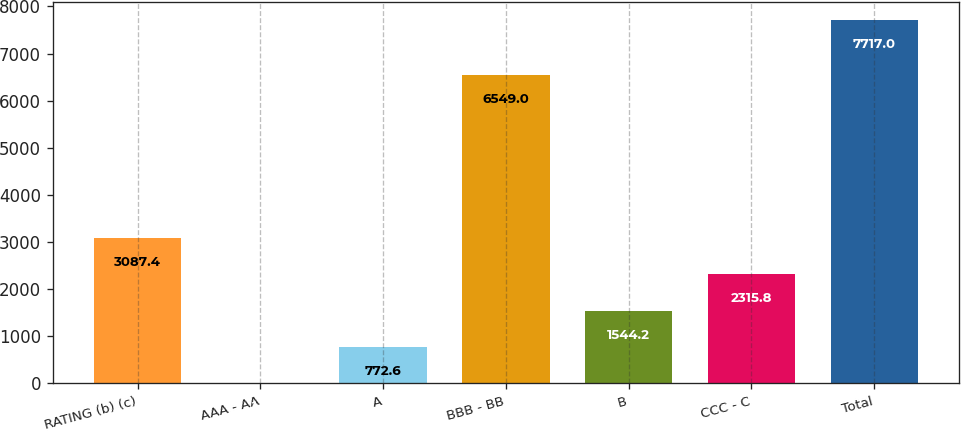<chart> <loc_0><loc_0><loc_500><loc_500><bar_chart><fcel>RATING (b) (c)<fcel>AAA - AA<fcel>A<fcel>BBB - BB<fcel>B<fcel>CCC - C<fcel>Total<nl><fcel>3087.4<fcel>1<fcel>772.6<fcel>6549<fcel>1544.2<fcel>2315.8<fcel>7717<nl></chart> 